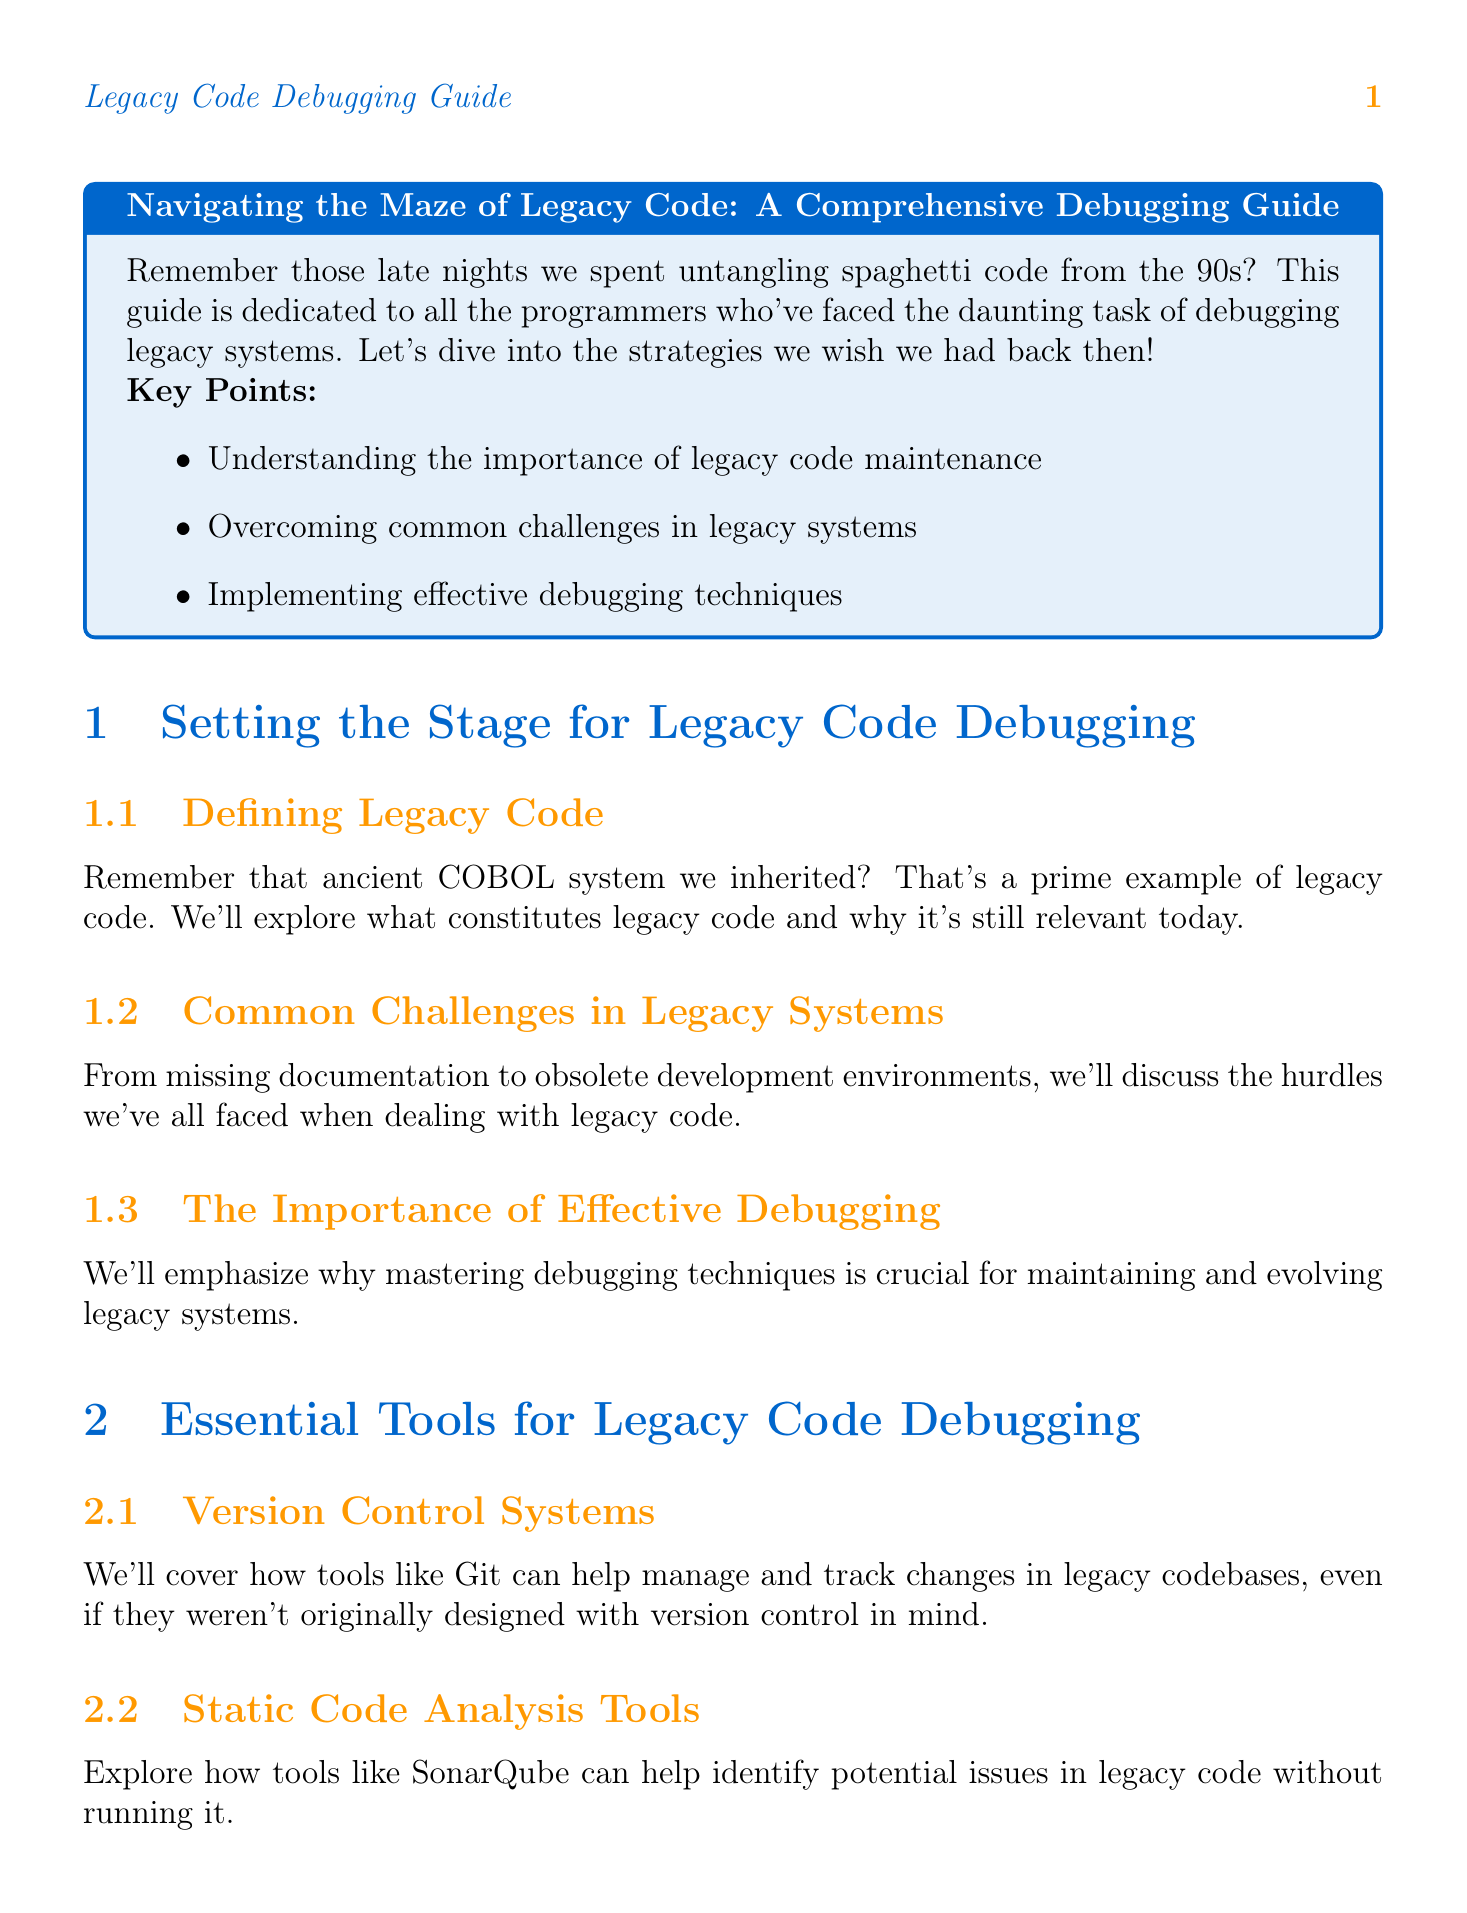What is the title of the guide? The title of the guide is stated at the beginning of the document as "Navigating the Maze of Legacy Code: A Comprehensive Debugging Guide."
Answer: Navigating the Maze of Legacy Code: A Comprehensive Debugging Guide What is a key point mentioned in the introduction? The introduction lists key points, one of which is "Understanding the importance of legacy code maintenance."
Answer: Understanding the importance of legacy code maintenance What chapter discusses version control systems? The chapter that covers version control systems is labeled "Chapter 2: Essential Tools for Legacy Code Debugging."
Answer: Chapter 2: Essential Tools for Legacy Code Debugging Which strategy is suggested for gradual migration techniques? The document suggests "Gradual Migration Techniques" under Chapter 3 for handling outdated libraries.
Answer: Gradual Migration Techniques What tool is recommended for static code analysis? The document recommends "SonarQube" for static code analysis in legacy code.
Answer: SonarQube What is the focus of Chapter 4? Chapter 4 is focused on "Tackling Undocumented Features," addressing challenges with undocumented code.
Answer: Tackling Undocumented Features How does the conclusion describe debugging legacy code? The conclusion describes debugging legacy code as "an art as much as it is a science."
Answer: an art as much as it is a science Which appendix contains useful resources? Appendix A contains a curated list of useful resources.
Answer: Appendix A What type of examples does Appendix B provide? Appendix B provides real-world examples of successful legacy code debugging projects.
Answer: real-world examples of successful legacy code debugging projects 